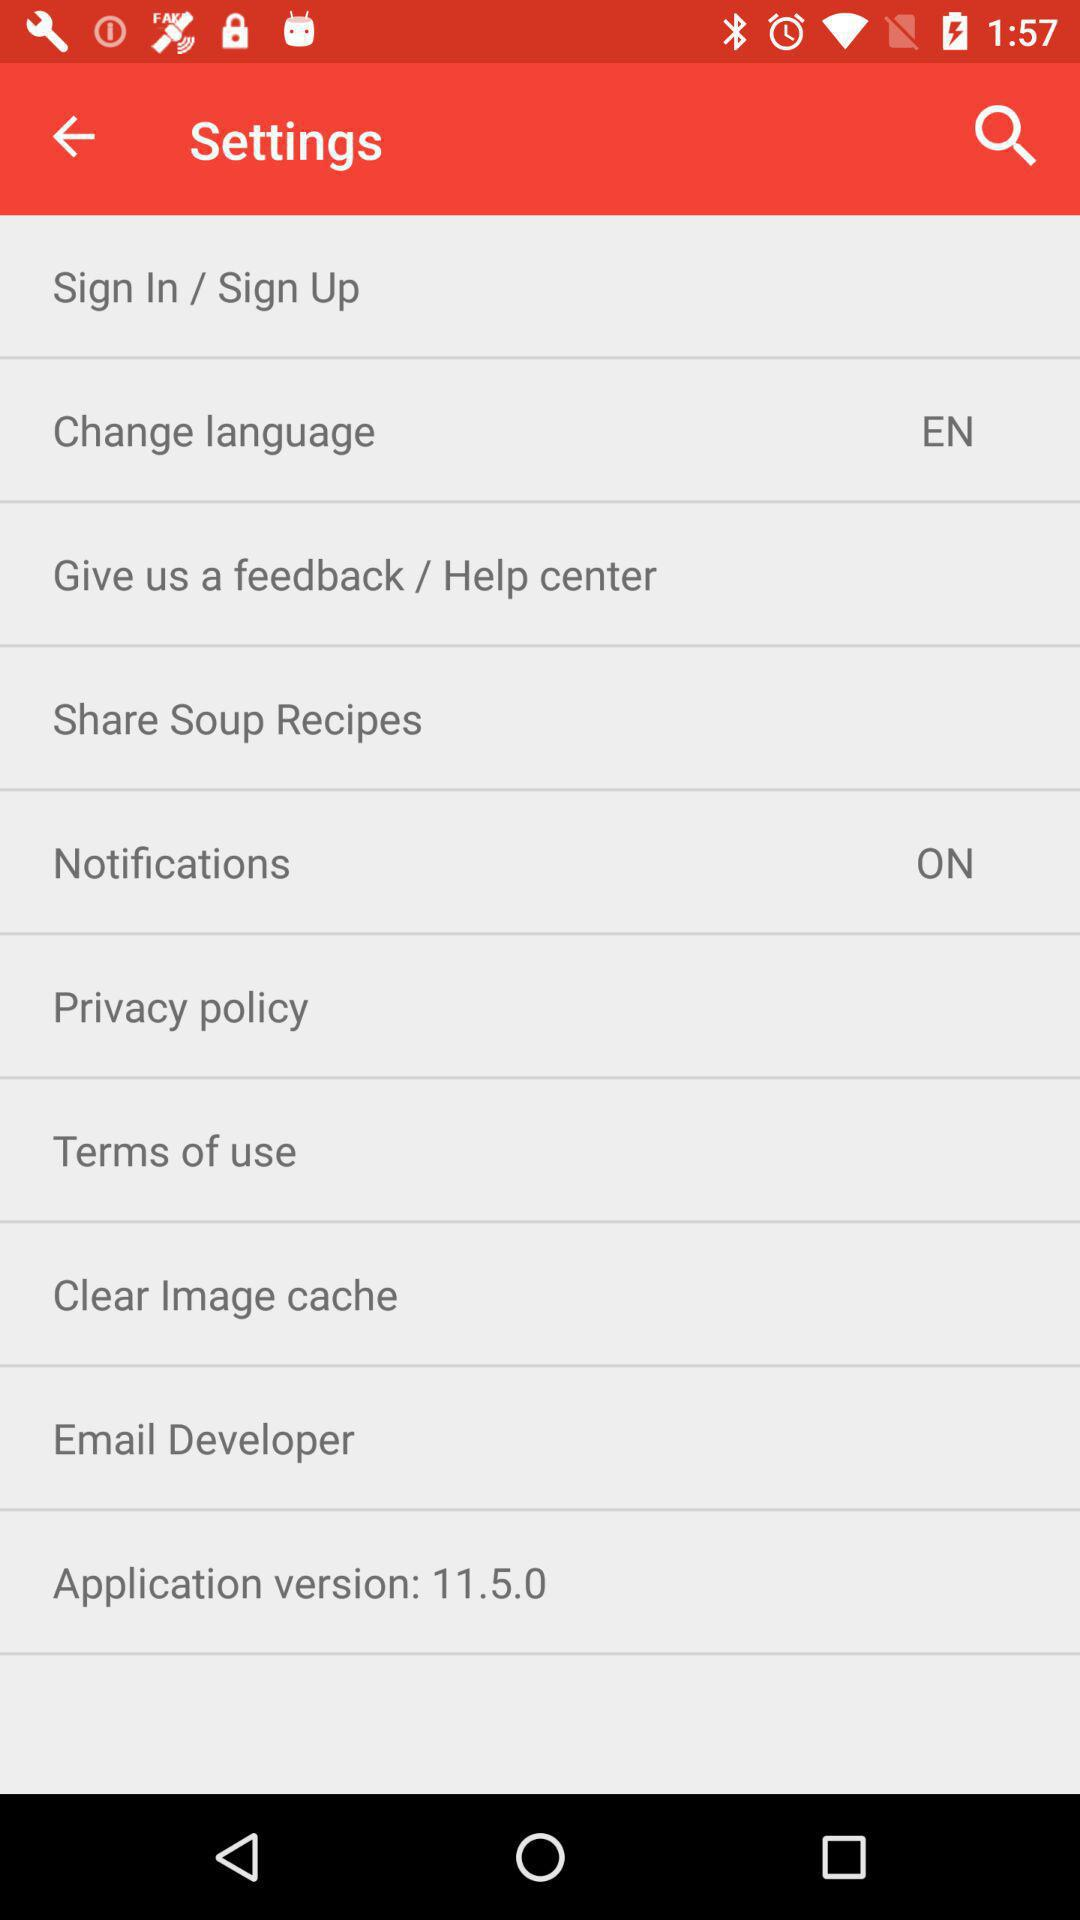What is the selected language? The selected language is "EN". 